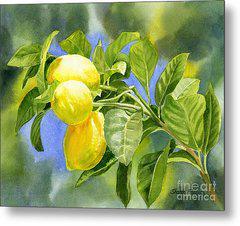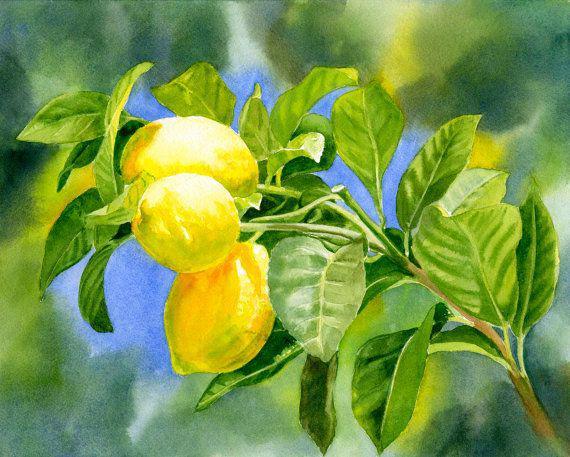The first image is the image on the left, the second image is the image on the right. For the images shown, is this caption "There are 6 lemons" true? Answer yes or no. Yes. 